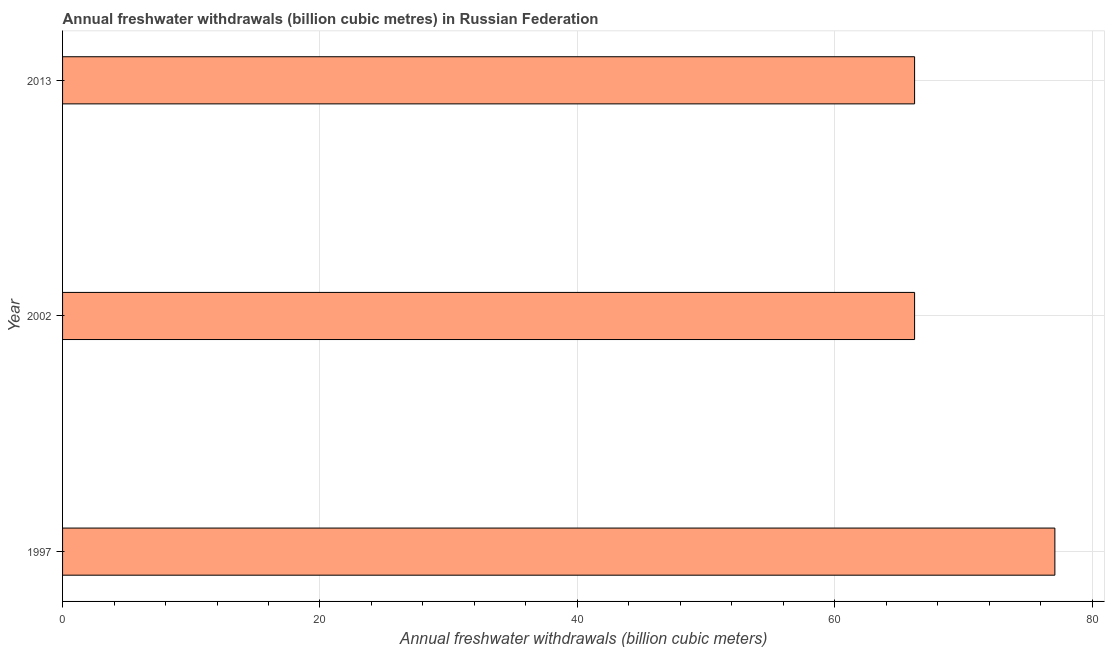Does the graph contain grids?
Keep it short and to the point. Yes. What is the title of the graph?
Ensure brevity in your answer.  Annual freshwater withdrawals (billion cubic metres) in Russian Federation. What is the label or title of the X-axis?
Offer a very short reply. Annual freshwater withdrawals (billion cubic meters). What is the annual freshwater withdrawals in 2002?
Keep it short and to the point. 66.2. Across all years, what is the maximum annual freshwater withdrawals?
Give a very brief answer. 77.1. Across all years, what is the minimum annual freshwater withdrawals?
Ensure brevity in your answer.  66.2. What is the sum of the annual freshwater withdrawals?
Your response must be concise. 209.5. What is the difference between the annual freshwater withdrawals in 1997 and 2013?
Give a very brief answer. 10.9. What is the average annual freshwater withdrawals per year?
Offer a terse response. 69.83. What is the median annual freshwater withdrawals?
Offer a terse response. 66.2. In how many years, is the annual freshwater withdrawals greater than 40 billion cubic meters?
Keep it short and to the point. 3. What is the ratio of the annual freshwater withdrawals in 1997 to that in 2002?
Keep it short and to the point. 1.17. Is the difference between the annual freshwater withdrawals in 1997 and 2002 greater than the difference between any two years?
Keep it short and to the point. Yes. What is the difference between the highest and the second highest annual freshwater withdrawals?
Make the answer very short. 10.9. What is the difference between the highest and the lowest annual freshwater withdrawals?
Provide a succinct answer. 10.9. In how many years, is the annual freshwater withdrawals greater than the average annual freshwater withdrawals taken over all years?
Provide a short and direct response. 1. How many bars are there?
Offer a very short reply. 3. How many years are there in the graph?
Ensure brevity in your answer.  3. Are the values on the major ticks of X-axis written in scientific E-notation?
Ensure brevity in your answer.  No. What is the Annual freshwater withdrawals (billion cubic meters) of 1997?
Ensure brevity in your answer.  77.1. What is the Annual freshwater withdrawals (billion cubic meters) of 2002?
Offer a very short reply. 66.2. What is the Annual freshwater withdrawals (billion cubic meters) of 2013?
Your response must be concise. 66.2. What is the difference between the Annual freshwater withdrawals (billion cubic meters) in 1997 and 2013?
Your answer should be compact. 10.9. What is the ratio of the Annual freshwater withdrawals (billion cubic meters) in 1997 to that in 2002?
Your answer should be very brief. 1.17. What is the ratio of the Annual freshwater withdrawals (billion cubic meters) in 1997 to that in 2013?
Give a very brief answer. 1.17. 